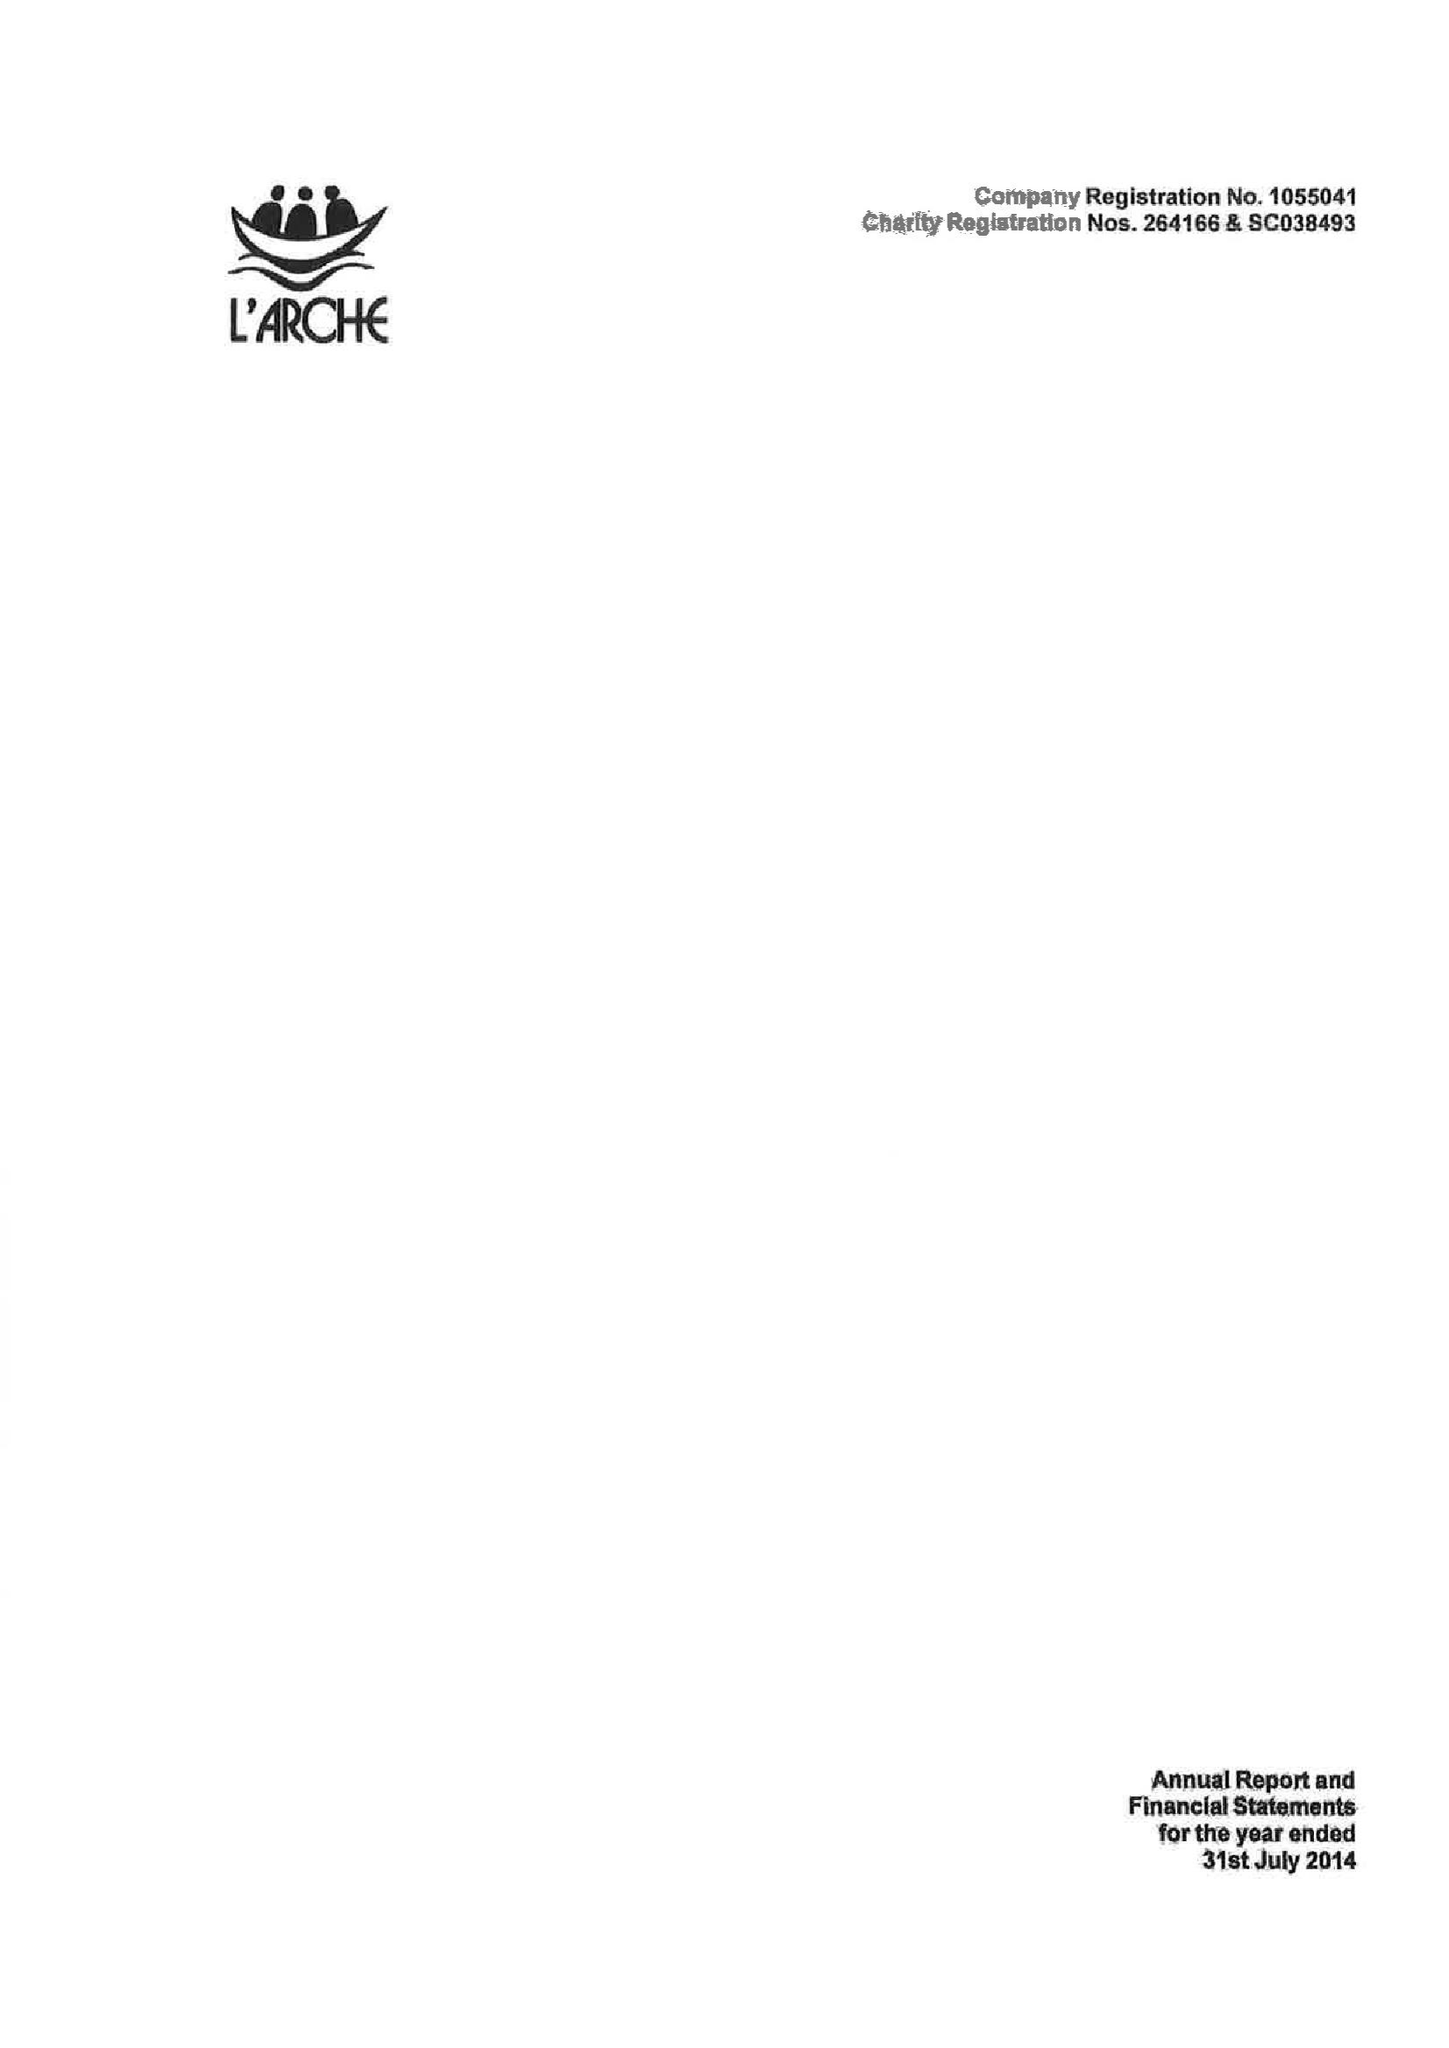What is the value for the address__post_town?
Answer the question using a single word or phrase. KEIGHLEY 